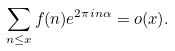<formula> <loc_0><loc_0><loc_500><loc_500>\sum _ { n \leq x } f ( n ) e ^ { 2 \pi i n \alpha } = o ( x ) .</formula> 